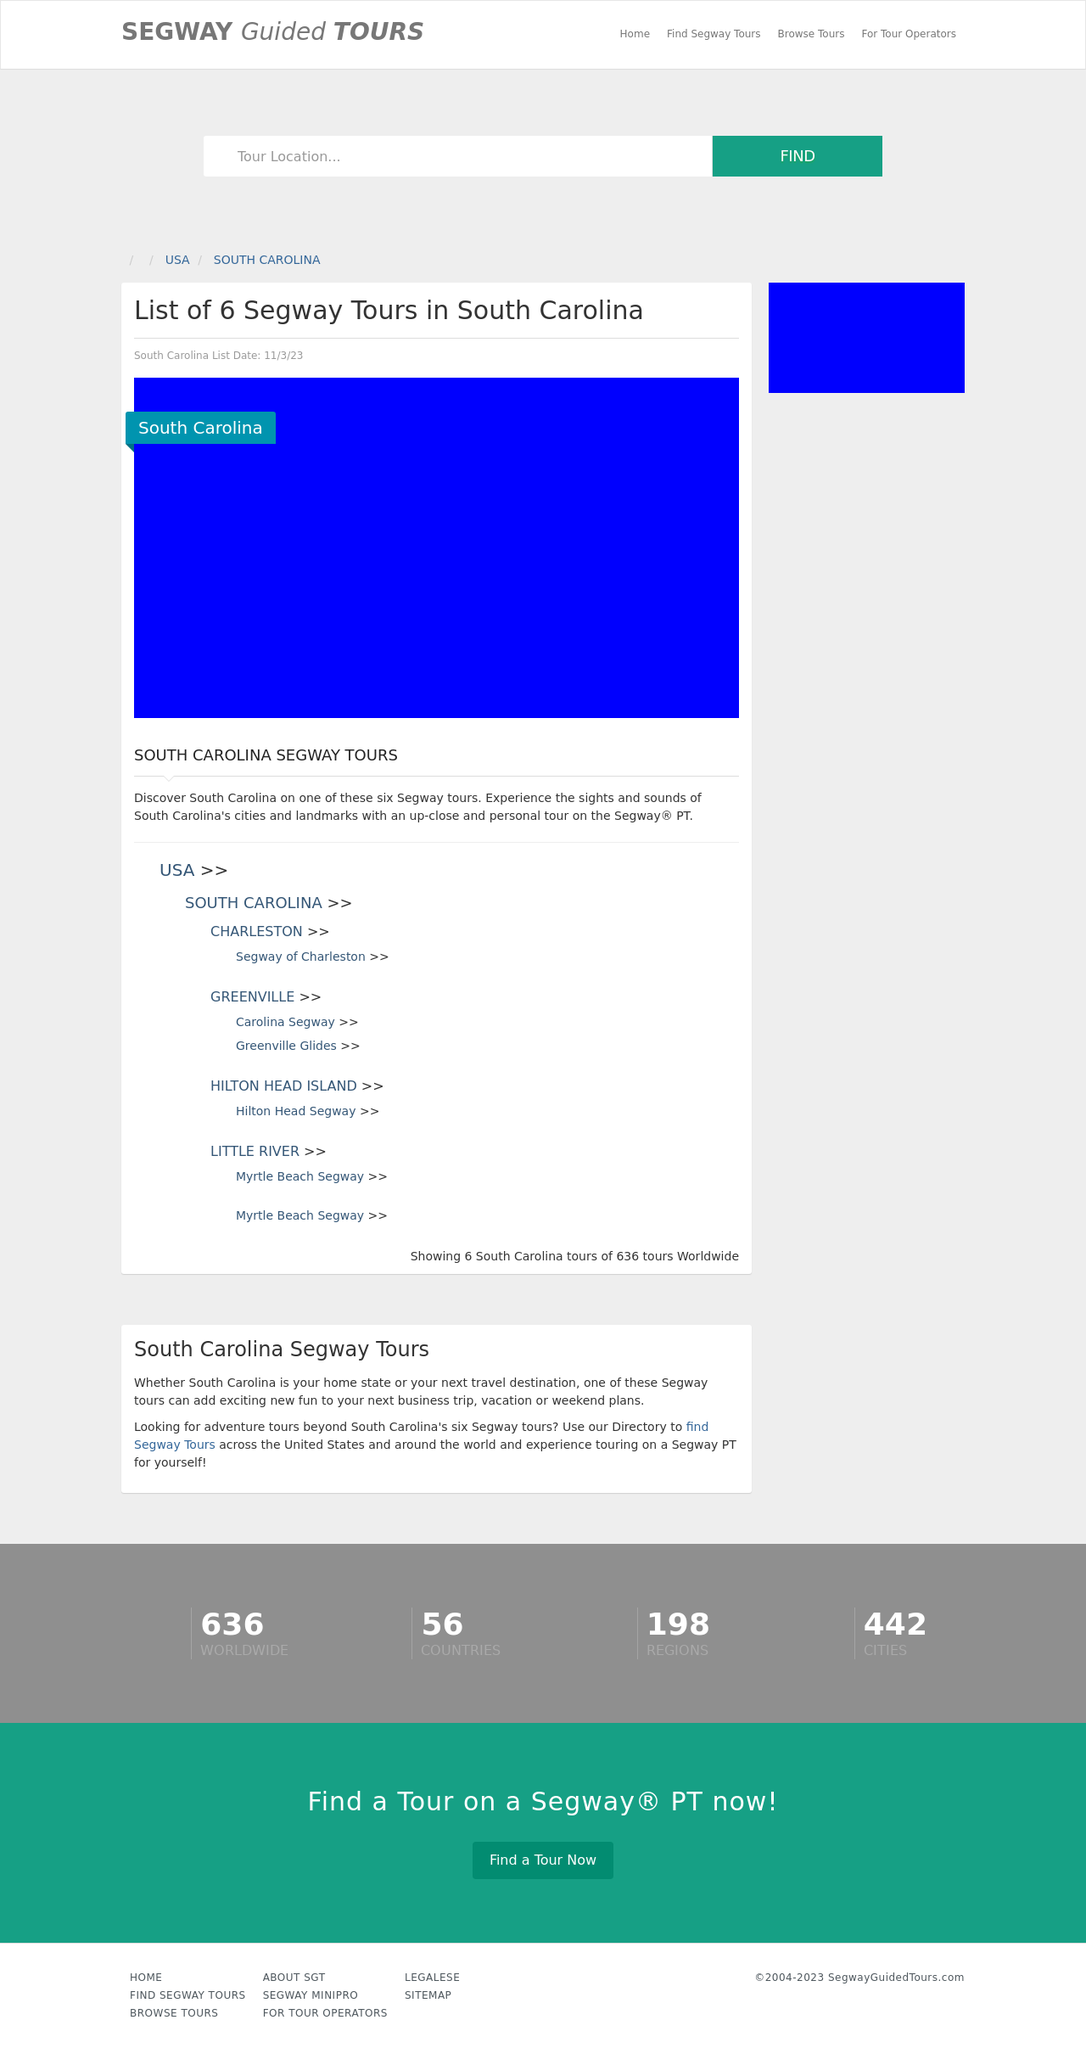What are the top attractions or landmarks featured in the Segway tours in Hilton Head Island? Hilton Head Island Segway tours typically feature several key attractions. Participants often explore the scenic pathways around the island, visit popular spots like the Harbour Town Lighthouse, and enjoy the lush landscapes of the coastal environment. These tours provide a great balance of adventure, nature, and local history. 